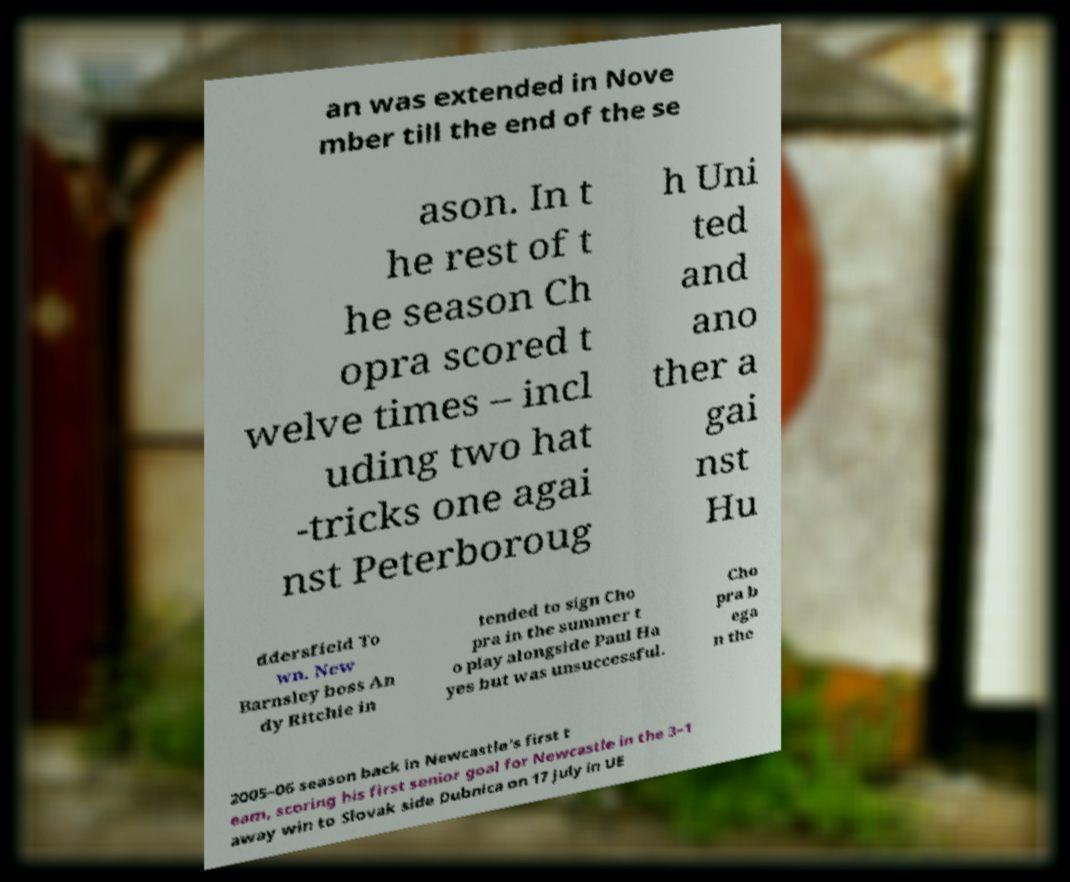Please read and relay the text visible in this image. What does it say? an was extended in Nove mber till the end of the se ason. In t he rest of t he season Ch opra scored t welve times – incl uding two hat -tricks one agai nst Peterboroug h Uni ted and ano ther a gai nst Hu ddersfield To wn. New Barnsley boss An dy Ritchie in tended to sign Cho pra in the summer t o play alongside Paul Ha yes but was unsuccessful. Cho pra b ega n the 2005–06 season back in Newcastle's first t eam, scoring his first senior goal for Newcastle in the 3–1 away win to Slovak side Dubnica on 17 July in UE 